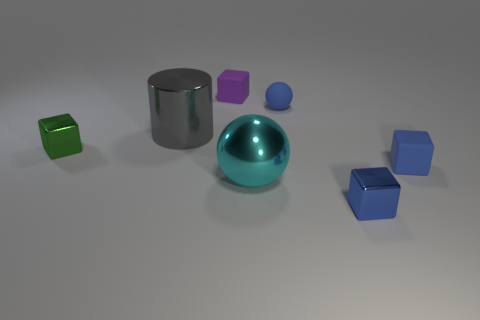Add 2 large gray matte objects. How many objects exist? 9 Subtract all blue cylinders. How many cyan spheres are left? 1 Subtract all cyan spheres. How many spheres are left? 1 Subtract all small blue metallic cubes. How many cubes are left? 3 Subtract 1 cubes. How many cubes are left? 3 Subtract all green blocks. Subtract all gray balls. How many blocks are left? 3 Subtract all blocks. Subtract all large balls. How many objects are left? 2 Add 4 small blue rubber spheres. How many small blue rubber spheres are left? 5 Add 7 spheres. How many spheres exist? 9 Subtract 1 gray cylinders. How many objects are left? 6 